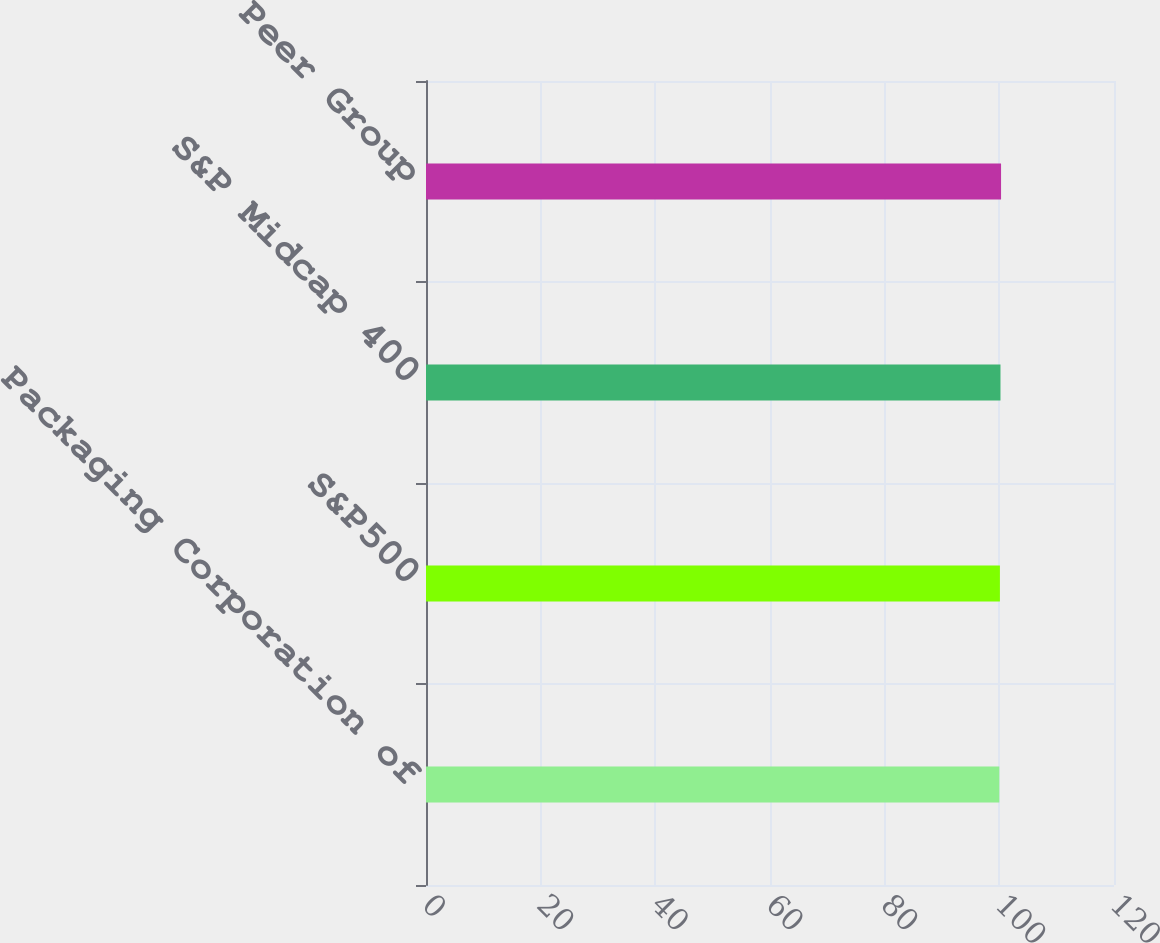<chart> <loc_0><loc_0><loc_500><loc_500><bar_chart><fcel>Packaging Corporation of<fcel>S&P500<fcel>S&P Midcap 400<fcel>Peer Group<nl><fcel>100<fcel>100.1<fcel>100.2<fcel>100.3<nl></chart> 